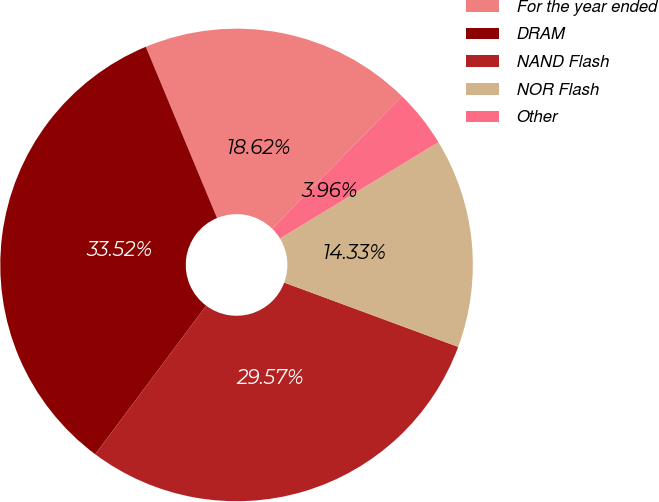Convert chart to OTSL. <chart><loc_0><loc_0><loc_500><loc_500><pie_chart><fcel>For the year ended<fcel>DRAM<fcel>NAND Flash<fcel>NOR Flash<fcel>Other<nl><fcel>18.62%<fcel>33.52%<fcel>29.57%<fcel>14.33%<fcel>3.96%<nl></chart> 